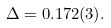Convert formula to latex. <formula><loc_0><loc_0><loc_500><loc_500>\Delta = 0 . 1 7 2 ( 3 ) .</formula> 